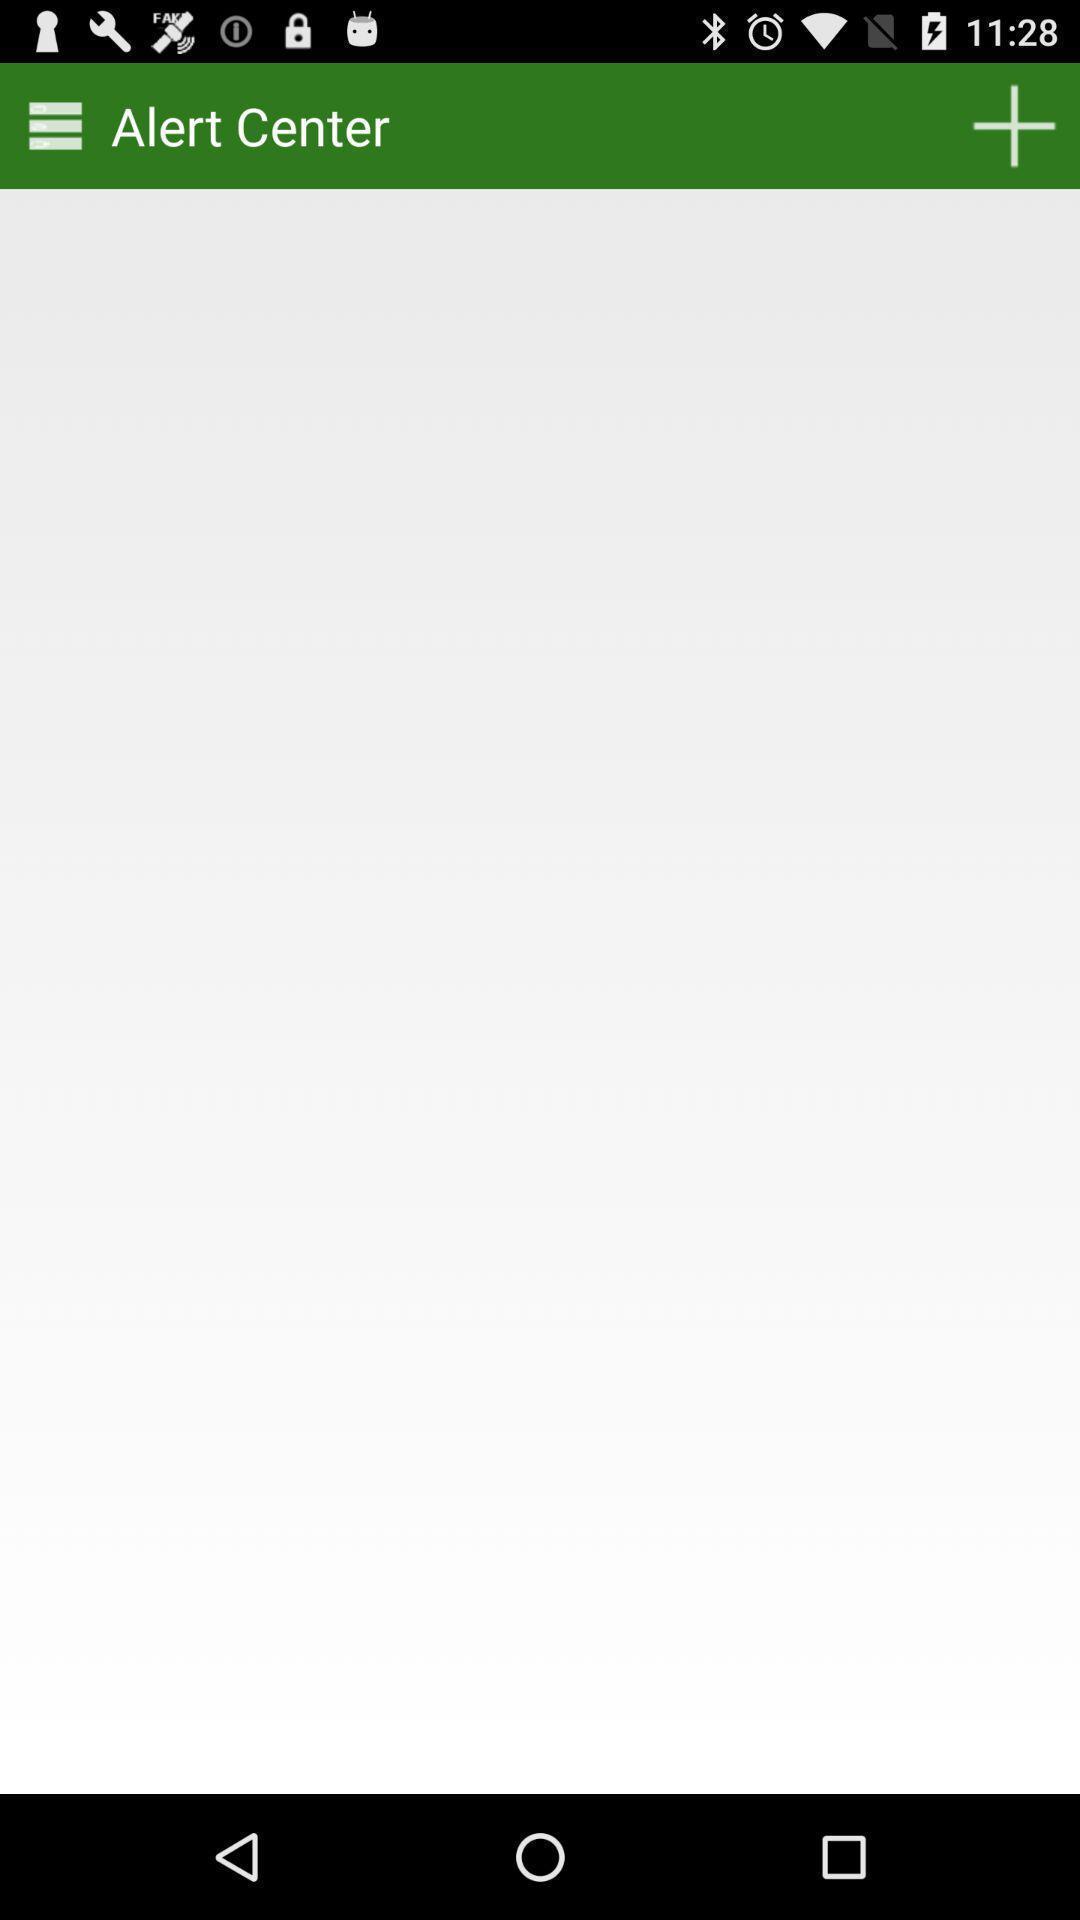What can you discern from this picture? Screen displaying the page with add icon and menu icon. 